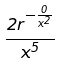<formula> <loc_0><loc_0><loc_500><loc_500>\frac { 2 r ^ { - \frac { 0 } { x ^ { 2 } } } } { x ^ { 5 } }</formula> 